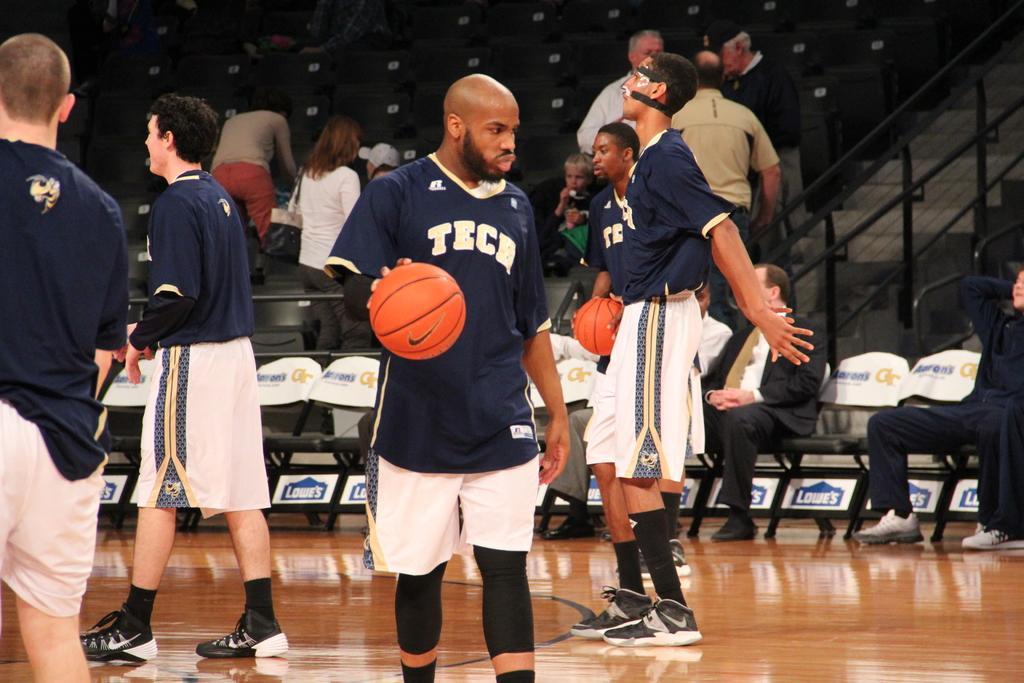How would you summarize this image in a sentence or two? In the picture I can see people, among them some are standing on the floor and some are sitting on chairs. I can also see two men in the front are holding balls in hands. In the background I can see chairs, fence and some other objects. 